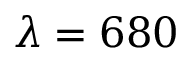Convert formula to latex. <formula><loc_0><loc_0><loc_500><loc_500>\lambda = 6 8 0</formula> 